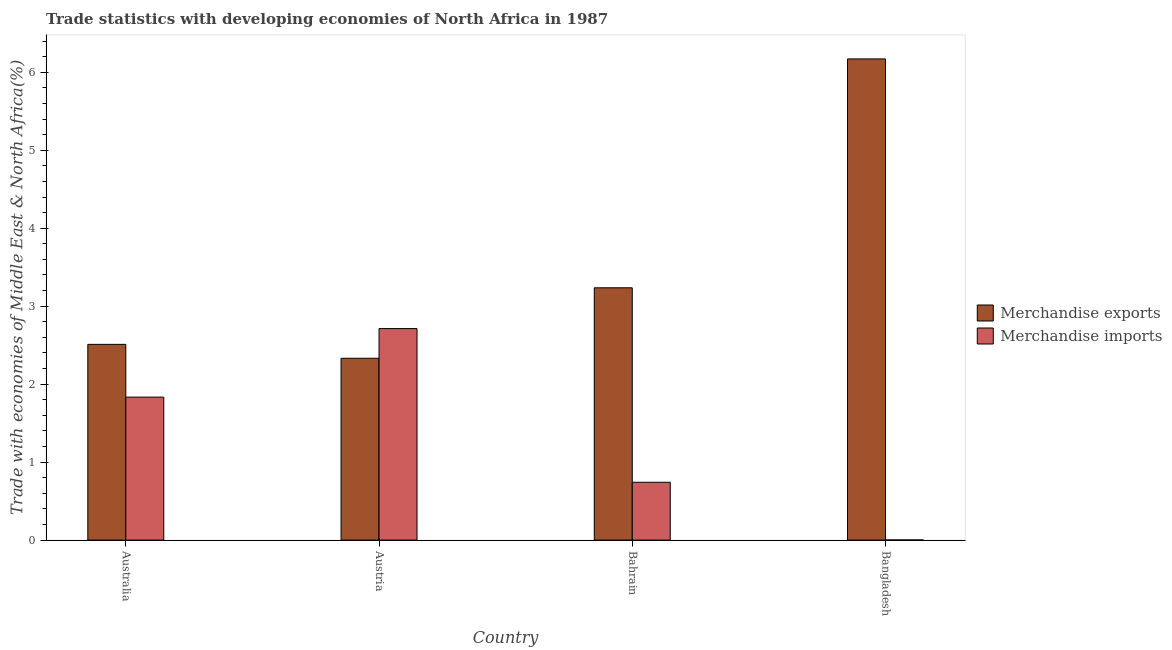Are the number of bars per tick equal to the number of legend labels?
Your answer should be compact. Yes. Are the number of bars on each tick of the X-axis equal?
Your answer should be compact. Yes. How many bars are there on the 2nd tick from the right?
Offer a very short reply. 2. What is the label of the 3rd group of bars from the left?
Provide a succinct answer. Bahrain. In how many cases, is the number of bars for a given country not equal to the number of legend labels?
Your answer should be very brief. 0. What is the merchandise imports in Austria?
Provide a short and direct response. 2.71. Across all countries, what is the maximum merchandise imports?
Provide a succinct answer. 2.71. Across all countries, what is the minimum merchandise imports?
Your answer should be very brief. 0. In which country was the merchandise exports maximum?
Provide a succinct answer. Bangladesh. What is the total merchandise exports in the graph?
Your answer should be compact. 14.25. What is the difference between the merchandise exports in Australia and that in Austria?
Ensure brevity in your answer.  0.18. What is the difference between the merchandise imports in Bangladesh and the merchandise exports in Austria?
Your answer should be compact. -2.33. What is the average merchandise exports per country?
Keep it short and to the point. 3.56. What is the difference between the merchandise imports and merchandise exports in Australia?
Your answer should be very brief. -0.68. In how many countries, is the merchandise imports greater than 5.6 %?
Your answer should be compact. 0. What is the ratio of the merchandise imports in Bahrain to that in Bangladesh?
Your answer should be very brief. 424.08. Is the difference between the merchandise exports in Austria and Bahrain greater than the difference between the merchandise imports in Austria and Bahrain?
Your answer should be very brief. No. What is the difference between the highest and the second highest merchandise exports?
Offer a terse response. 2.94. What is the difference between the highest and the lowest merchandise exports?
Your answer should be compact. 3.84. In how many countries, is the merchandise imports greater than the average merchandise imports taken over all countries?
Keep it short and to the point. 2. Is the sum of the merchandise exports in Australia and Austria greater than the maximum merchandise imports across all countries?
Your answer should be very brief. Yes. What does the 1st bar from the left in Australia represents?
Provide a succinct answer. Merchandise exports. Are the values on the major ticks of Y-axis written in scientific E-notation?
Your answer should be very brief. No. Does the graph contain grids?
Provide a succinct answer. No. How many legend labels are there?
Provide a short and direct response. 2. What is the title of the graph?
Offer a very short reply. Trade statistics with developing economies of North Africa in 1987. What is the label or title of the X-axis?
Offer a terse response. Country. What is the label or title of the Y-axis?
Provide a succinct answer. Trade with economies of Middle East & North Africa(%). What is the Trade with economies of Middle East & North Africa(%) in Merchandise exports in Australia?
Your response must be concise. 2.51. What is the Trade with economies of Middle East & North Africa(%) of Merchandise imports in Australia?
Make the answer very short. 1.83. What is the Trade with economies of Middle East & North Africa(%) in Merchandise exports in Austria?
Provide a succinct answer. 2.33. What is the Trade with economies of Middle East & North Africa(%) of Merchandise imports in Austria?
Offer a very short reply. 2.71. What is the Trade with economies of Middle East & North Africa(%) in Merchandise exports in Bahrain?
Your response must be concise. 3.24. What is the Trade with economies of Middle East & North Africa(%) in Merchandise imports in Bahrain?
Provide a succinct answer. 0.74. What is the Trade with economies of Middle East & North Africa(%) in Merchandise exports in Bangladesh?
Give a very brief answer. 6.17. What is the Trade with economies of Middle East & North Africa(%) in Merchandise imports in Bangladesh?
Make the answer very short. 0. Across all countries, what is the maximum Trade with economies of Middle East & North Africa(%) in Merchandise exports?
Ensure brevity in your answer.  6.17. Across all countries, what is the maximum Trade with economies of Middle East & North Africa(%) in Merchandise imports?
Your answer should be very brief. 2.71. Across all countries, what is the minimum Trade with economies of Middle East & North Africa(%) in Merchandise exports?
Give a very brief answer. 2.33. Across all countries, what is the minimum Trade with economies of Middle East & North Africa(%) in Merchandise imports?
Provide a succinct answer. 0. What is the total Trade with economies of Middle East & North Africa(%) of Merchandise exports in the graph?
Provide a short and direct response. 14.25. What is the total Trade with economies of Middle East & North Africa(%) of Merchandise imports in the graph?
Offer a very short reply. 5.29. What is the difference between the Trade with economies of Middle East & North Africa(%) in Merchandise exports in Australia and that in Austria?
Provide a short and direct response. 0.18. What is the difference between the Trade with economies of Middle East & North Africa(%) of Merchandise imports in Australia and that in Austria?
Keep it short and to the point. -0.88. What is the difference between the Trade with economies of Middle East & North Africa(%) in Merchandise exports in Australia and that in Bahrain?
Ensure brevity in your answer.  -0.73. What is the difference between the Trade with economies of Middle East & North Africa(%) of Merchandise imports in Australia and that in Bahrain?
Provide a succinct answer. 1.09. What is the difference between the Trade with economies of Middle East & North Africa(%) in Merchandise exports in Australia and that in Bangladesh?
Ensure brevity in your answer.  -3.66. What is the difference between the Trade with economies of Middle East & North Africa(%) of Merchandise imports in Australia and that in Bangladesh?
Your response must be concise. 1.83. What is the difference between the Trade with economies of Middle East & North Africa(%) of Merchandise exports in Austria and that in Bahrain?
Your answer should be compact. -0.9. What is the difference between the Trade with economies of Middle East & North Africa(%) in Merchandise imports in Austria and that in Bahrain?
Offer a very short reply. 1.97. What is the difference between the Trade with economies of Middle East & North Africa(%) in Merchandise exports in Austria and that in Bangladesh?
Offer a very short reply. -3.84. What is the difference between the Trade with economies of Middle East & North Africa(%) of Merchandise imports in Austria and that in Bangladesh?
Your answer should be very brief. 2.71. What is the difference between the Trade with economies of Middle East & North Africa(%) of Merchandise exports in Bahrain and that in Bangladesh?
Your answer should be compact. -2.94. What is the difference between the Trade with economies of Middle East & North Africa(%) in Merchandise imports in Bahrain and that in Bangladesh?
Provide a short and direct response. 0.74. What is the difference between the Trade with economies of Middle East & North Africa(%) in Merchandise exports in Australia and the Trade with economies of Middle East & North Africa(%) in Merchandise imports in Austria?
Ensure brevity in your answer.  -0.2. What is the difference between the Trade with economies of Middle East & North Africa(%) of Merchandise exports in Australia and the Trade with economies of Middle East & North Africa(%) of Merchandise imports in Bahrain?
Offer a very short reply. 1.77. What is the difference between the Trade with economies of Middle East & North Africa(%) in Merchandise exports in Australia and the Trade with economies of Middle East & North Africa(%) in Merchandise imports in Bangladesh?
Offer a very short reply. 2.51. What is the difference between the Trade with economies of Middle East & North Africa(%) in Merchandise exports in Austria and the Trade with economies of Middle East & North Africa(%) in Merchandise imports in Bahrain?
Your answer should be compact. 1.59. What is the difference between the Trade with economies of Middle East & North Africa(%) in Merchandise exports in Austria and the Trade with economies of Middle East & North Africa(%) in Merchandise imports in Bangladesh?
Keep it short and to the point. 2.33. What is the difference between the Trade with economies of Middle East & North Africa(%) of Merchandise exports in Bahrain and the Trade with economies of Middle East & North Africa(%) of Merchandise imports in Bangladesh?
Provide a succinct answer. 3.23. What is the average Trade with economies of Middle East & North Africa(%) of Merchandise exports per country?
Your answer should be compact. 3.56. What is the average Trade with economies of Middle East & North Africa(%) in Merchandise imports per country?
Provide a short and direct response. 1.32. What is the difference between the Trade with economies of Middle East & North Africa(%) in Merchandise exports and Trade with economies of Middle East & North Africa(%) in Merchandise imports in Australia?
Your response must be concise. 0.68. What is the difference between the Trade with economies of Middle East & North Africa(%) of Merchandise exports and Trade with economies of Middle East & North Africa(%) of Merchandise imports in Austria?
Provide a succinct answer. -0.38. What is the difference between the Trade with economies of Middle East & North Africa(%) in Merchandise exports and Trade with economies of Middle East & North Africa(%) in Merchandise imports in Bahrain?
Provide a succinct answer. 2.49. What is the difference between the Trade with economies of Middle East & North Africa(%) of Merchandise exports and Trade with economies of Middle East & North Africa(%) of Merchandise imports in Bangladesh?
Your answer should be compact. 6.17. What is the ratio of the Trade with economies of Middle East & North Africa(%) in Merchandise exports in Australia to that in Austria?
Make the answer very short. 1.08. What is the ratio of the Trade with economies of Middle East & North Africa(%) in Merchandise imports in Australia to that in Austria?
Your answer should be compact. 0.68. What is the ratio of the Trade with economies of Middle East & North Africa(%) of Merchandise exports in Australia to that in Bahrain?
Keep it short and to the point. 0.78. What is the ratio of the Trade with economies of Middle East & North Africa(%) in Merchandise imports in Australia to that in Bahrain?
Provide a succinct answer. 2.47. What is the ratio of the Trade with economies of Middle East & North Africa(%) in Merchandise exports in Australia to that in Bangladesh?
Ensure brevity in your answer.  0.41. What is the ratio of the Trade with economies of Middle East & North Africa(%) in Merchandise imports in Australia to that in Bangladesh?
Ensure brevity in your answer.  1048.5. What is the ratio of the Trade with economies of Middle East & North Africa(%) in Merchandise exports in Austria to that in Bahrain?
Ensure brevity in your answer.  0.72. What is the ratio of the Trade with economies of Middle East & North Africa(%) of Merchandise imports in Austria to that in Bahrain?
Make the answer very short. 3.66. What is the ratio of the Trade with economies of Middle East & North Africa(%) in Merchandise exports in Austria to that in Bangladesh?
Keep it short and to the point. 0.38. What is the ratio of the Trade with economies of Middle East & North Africa(%) of Merchandise imports in Austria to that in Bangladesh?
Offer a terse response. 1551.14. What is the ratio of the Trade with economies of Middle East & North Africa(%) of Merchandise exports in Bahrain to that in Bangladesh?
Provide a succinct answer. 0.52. What is the ratio of the Trade with economies of Middle East & North Africa(%) of Merchandise imports in Bahrain to that in Bangladesh?
Your response must be concise. 424.08. What is the difference between the highest and the second highest Trade with economies of Middle East & North Africa(%) of Merchandise exports?
Your answer should be compact. 2.94. What is the difference between the highest and the second highest Trade with economies of Middle East & North Africa(%) of Merchandise imports?
Give a very brief answer. 0.88. What is the difference between the highest and the lowest Trade with economies of Middle East & North Africa(%) of Merchandise exports?
Your answer should be compact. 3.84. What is the difference between the highest and the lowest Trade with economies of Middle East & North Africa(%) in Merchandise imports?
Ensure brevity in your answer.  2.71. 